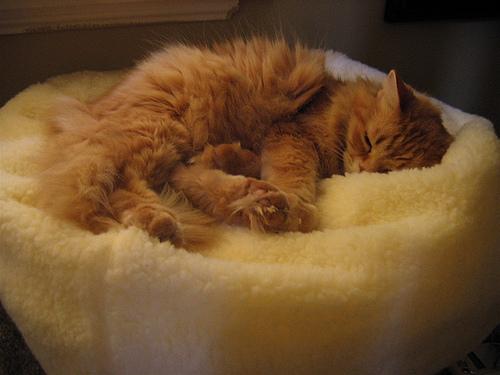Could this be catnapping?
Quick response, please. Yes. What is the cat doing?
Keep it brief. Sleeping. Is the cats hair standing up?
Write a very short answer. Yes. 